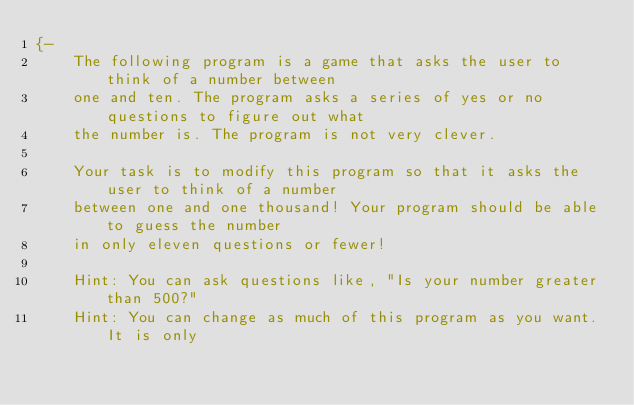Convert code to text. <code><loc_0><loc_0><loc_500><loc_500><_Haskell_>{-
    The following program is a game that asks the user to think of a number between 
    one and ten. The program asks a series of yes or no questions to figure out what
    the number is. The program is not very clever.
    
    Your task is to modify this program so that it asks the user to think of a number
    between one and one thousand! Your program should be able to guess the number 
    in only eleven questions or fewer! 
    
    Hint: You can ask questions like, "Is your number greater than 500?"
    Hint: You can change as much of this program as you want. It is only</code> 